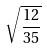<formula> <loc_0><loc_0><loc_500><loc_500>\sqrt { \frac { 1 2 } { 3 5 } }</formula> 